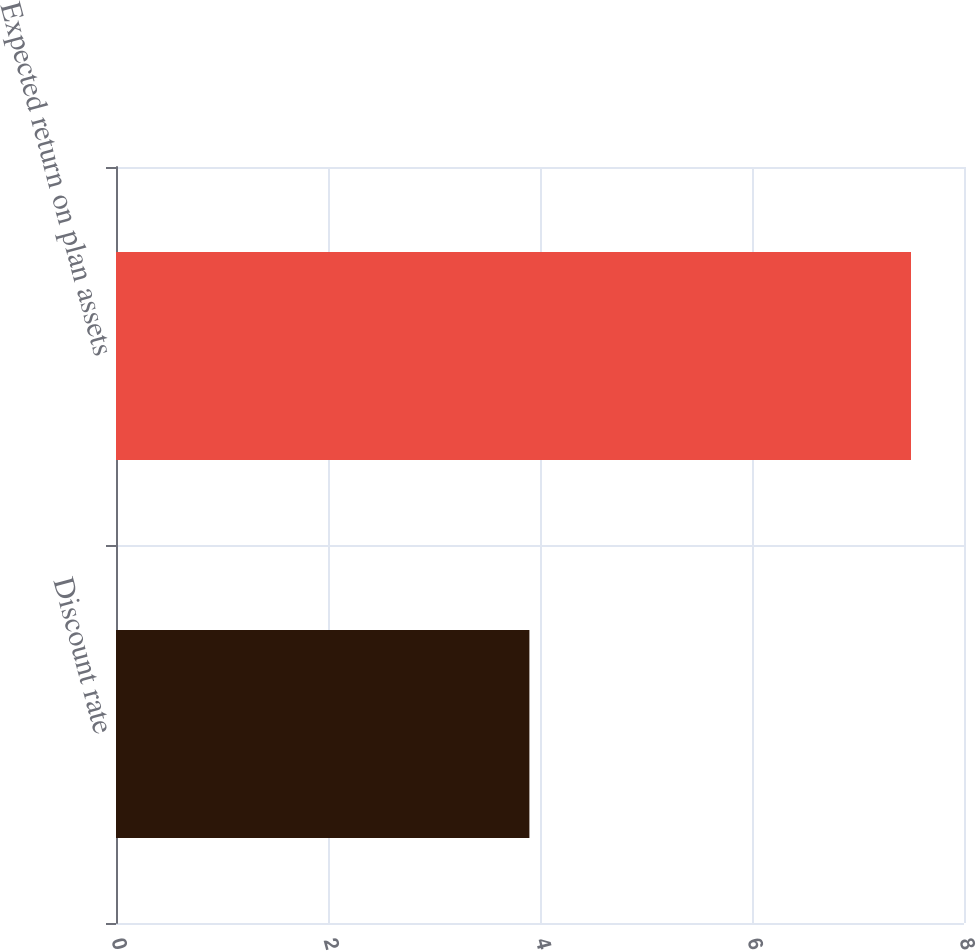Convert chart. <chart><loc_0><loc_0><loc_500><loc_500><bar_chart><fcel>Discount rate<fcel>Expected return on plan assets<nl><fcel>3.9<fcel>7.5<nl></chart> 